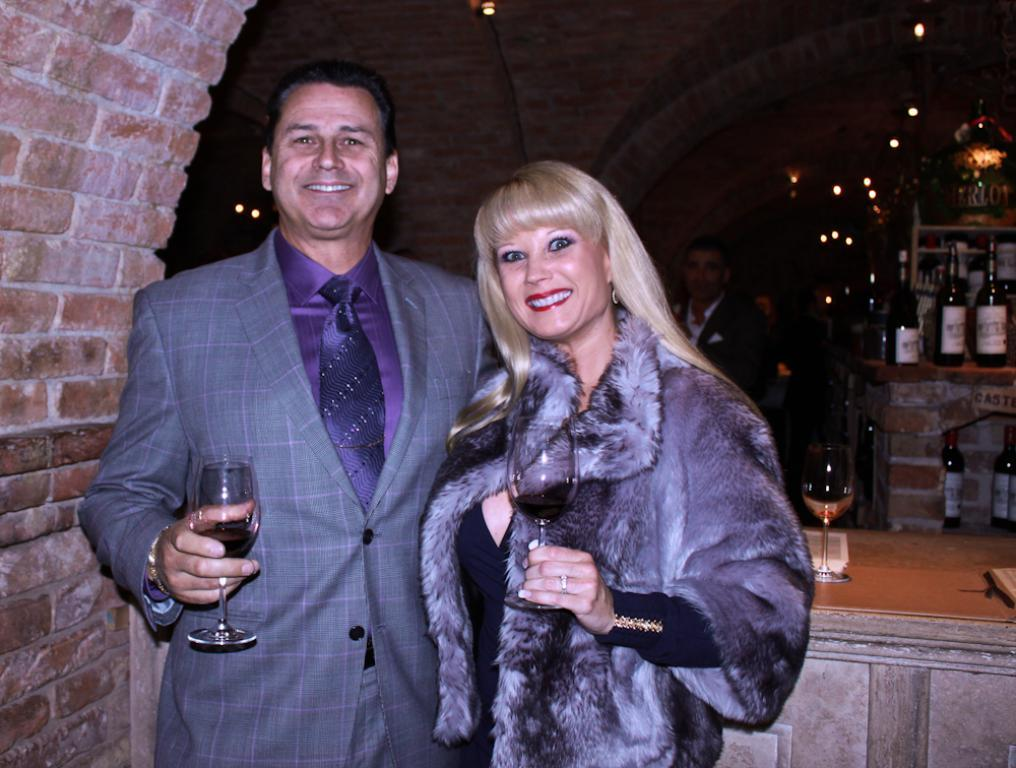How many people are present in the image? There are two people, a man and a woman, present in the image. What are the man and the woman doing in the image? The man and the woman are posing for a camera and holding glasses in their hands. What is the emotional expression of the man and the woman in the image? The man and the woman are smiling in the image. What can be seen in the background of the image? There are lights, bottles, a glass object, a rack, a wall, and a person in the background of the image. What type of quiver can be seen hanging on the wall in the image? There is no quiver present in the image; only lights, bottles, a glass object, a rack, a wall, and a person can be seen in the background. What kind of badge is the person in the background wearing? There is no person wearing a badge in the image; only the man, the woman, and the background elements are visible. 